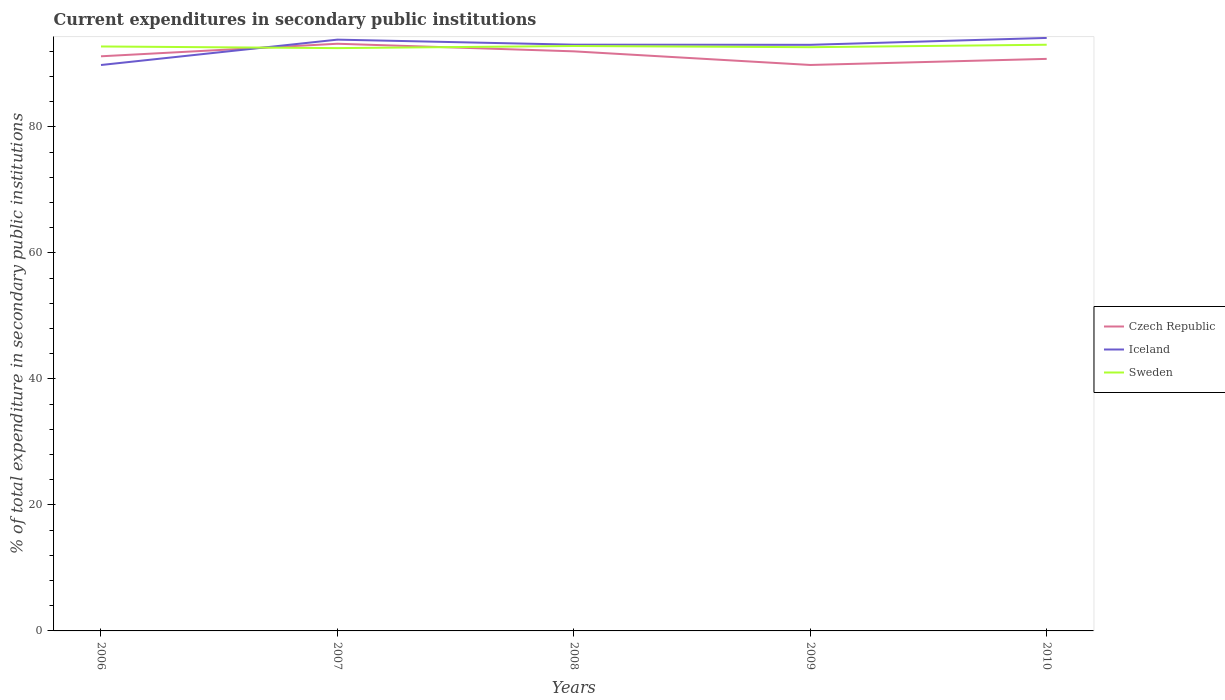How many different coloured lines are there?
Give a very brief answer. 3. Does the line corresponding to Czech Republic intersect with the line corresponding to Sweden?
Your answer should be compact. Yes. Across all years, what is the maximum current expenditures in secondary public institutions in Czech Republic?
Offer a terse response. 89.81. What is the total current expenditures in secondary public institutions in Sweden in the graph?
Your response must be concise. -0.28. What is the difference between the highest and the second highest current expenditures in secondary public institutions in Iceland?
Provide a succinct answer. 4.3. Is the current expenditures in secondary public institutions in Iceland strictly greater than the current expenditures in secondary public institutions in Czech Republic over the years?
Make the answer very short. No. How many lines are there?
Your answer should be very brief. 3. How many years are there in the graph?
Provide a succinct answer. 5. What is the difference between two consecutive major ticks on the Y-axis?
Your answer should be very brief. 20. Does the graph contain any zero values?
Give a very brief answer. No. Does the graph contain grids?
Offer a very short reply. No. How are the legend labels stacked?
Provide a short and direct response. Vertical. What is the title of the graph?
Provide a short and direct response. Current expenditures in secondary public institutions. Does "High income" appear as one of the legend labels in the graph?
Ensure brevity in your answer.  No. What is the label or title of the X-axis?
Make the answer very short. Years. What is the label or title of the Y-axis?
Provide a succinct answer. % of total expenditure in secondary public institutions. What is the % of total expenditure in secondary public institutions of Czech Republic in 2006?
Your response must be concise. 91.19. What is the % of total expenditure in secondary public institutions in Iceland in 2006?
Give a very brief answer. 89.81. What is the % of total expenditure in secondary public institutions of Sweden in 2006?
Keep it short and to the point. 92.75. What is the % of total expenditure in secondary public institutions of Czech Republic in 2007?
Your answer should be compact. 93.18. What is the % of total expenditure in secondary public institutions of Iceland in 2007?
Provide a succinct answer. 93.83. What is the % of total expenditure in secondary public institutions of Sweden in 2007?
Offer a terse response. 92.49. What is the % of total expenditure in secondary public institutions in Czech Republic in 2008?
Offer a terse response. 91.98. What is the % of total expenditure in secondary public institutions in Iceland in 2008?
Provide a short and direct response. 93.03. What is the % of total expenditure in secondary public institutions of Sweden in 2008?
Your response must be concise. 92.82. What is the % of total expenditure in secondary public institutions in Czech Republic in 2009?
Offer a terse response. 89.81. What is the % of total expenditure in secondary public institutions of Iceland in 2009?
Provide a succinct answer. 93.01. What is the % of total expenditure in secondary public institutions of Sweden in 2009?
Your answer should be very brief. 92.63. What is the % of total expenditure in secondary public institutions in Czech Republic in 2010?
Ensure brevity in your answer.  90.78. What is the % of total expenditure in secondary public institutions in Iceland in 2010?
Offer a very short reply. 94.1. What is the % of total expenditure in secondary public institutions of Sweden in 2010?
Ensure brevity in your answer.  93.02. Across all years, what is the maximum % of total expenditure in secondary public institutions of Czech Republic?
Offer a very short reply. 93.18. Across all years, what is the maximum % of total expenditure in secondary public institutions in Iceland?
Provide a succinct answer. 94.1. Across all years, what is the maximum % of total expenditure in secondary public institutions of Sweden?
Your answer should be compact. 93.02. Across all years, what is the minimum % of total expenditure in secondary public institutions of Czech Republic?
Make the answer very short. 89.81. Across all years, what is the minimum % of total expenditure in secondary public institutions in Iceland?
Give a very brief answer. 89.81. Across all years, what is the minimum % of total expenditure in secondary public institutions in Sweden?
Offer a terse response. 92.49. What is the total % of total expenditure in secondary public institutions in Czech Republic in the graph?
Make the answer very short. 456.94. What is the total % of total expenditure in secondary public institutions of Iceland in the graph?
Your answer should be compact. 463.79. What is the total % of total expenditure in secondary public institutions of Sweden in the graph?
Your answer should be very brief. 463.72. What is the difference between the % of total expenditure in secondary public institutions in Czech Republic in 2006 and that in 2007?
Ensure brevity in your answer.  -1.99. What is the difference between the % of total expenditure in secondary public institutions of Iceland in 2006 and that in 2007?
Your answer should be compact. -4.03. What is the difference between the % of total expenditure in secondary public institutions in Sweden in 2006 and that in 2007?
Your answer should be very brief. 0.26. What is the difference between the % of total expenditure in secondary public institutions of Czech Republic in 2006 and that in 2008?
Offer a very short reply. -0.79. What is the difference between the % of total expenditure in secondary public institutions in Iceland in 2006 and that in 2008?
Your response must be concise. -3.23. What is the difference between the % of total expenditure in secondary public institutions in Sweden in 2006 and that in 2008?
Provide a short and direct response. -0.07. What is the difference between the % of total expenditure in secondary public institutions of Czech Republic in 2006 and that in 2009?
Keep it short and to the point. 1.38. What is the difference between the % of total expenditure in secondary public institutions of Iceland in 2006 and that in 2009?
Keep it short and to the point. -3.2. What is the difference between the % of total expenditure in secondary public institutions in Sweden in 2006 and that in 2009?
Ensure brevity in your answer.  0.11. What is the difference between the % of total expenditure in secondary public institutions in Czech Republic in 2006 and that in 2010?
Provide a succinct answer. 0.41. What is the difference between the % of total expenditure in secondary public institutions of Iceland in 2006 and that in 2010?
Provide a succinct answer. -4.3. What is the difference between the % of total expenditure in secondary public institutions in Sweden in 2006 and that in 2010?
Keep it short and to the point. -0.28. What is the difference between the % of total expenditure in secondary public institutions of Czech Republic in 2007 and that in 2008?
Give a very brief answer. 1.2. What is the difference between the % of total expenditure in secondary public institutions in Iceland in 2007 and that in 2008?
Give a very brief answer. 0.8. What is the difference between the % of total expenditure in secondary public institutions of Sweden in 2007 and that in 2008?
Offer a very short reply. -0.33. What is the difference between the % of total expenditure in secondary public institutions of Czech Republic in 2007 and that in 2009?
Your response must be concise. 3.37. What is the difference between the % of total expenditure in secondary public institutions in Iceland in 2007 and that in 2009?
Ensure brevity in your answer.  0.82. What is the difference between the % of total expenditure in secondary public institutions of Sweden in 2007 and that in 2009?
Offer a terse response. -0.15. What is the difference between the % of total expenditure in secondary public institutions in Czech Republic in 2007 and that in 2010?
Provide a succinct answer. 2.4. What is the difference between the % of total expenditure in secondary public institutions in Iceland in 2007 and that in 2010?
Your answer should be compact. -0.27. What is the difference between the % of total expenditure in secondary public institutions in Sweden in 2007 and that in 2010?
Provide a succinct answer. -0.54. What is the difference between the % of total expenditure in secondary public institutions of Czech Republic in 2008 and that in 2009?
Ensure brevity in your answer.  2.16. What is the difference between the % of total expenditure in secondary public institutions in Iceland in 2008 and that in 2009?
Give a very brief answer. 0.02. What is the difference between the % of total expenditure in secondary public institutions in Sweden in 2008 and that in 2009?
Your response must be concise. 0.19. What is the difference between the % of total expenditure in secondary public institutions in Czech Republic in 2008 and that in 2010?
Provide a short and direct response. 1.2. What is the difference between the % of total expenditure in secondary public institutions of Iceland in 2008 and that in 2010?
Make the answer very short. -1.07. What is the difference between the % of total expenditure in secondary public institutions in Sweden in 2008 and that in 2010?
Ensure brevity in your answer.  -0.2. What is the difference between the % of total expenditure in secondary public institutions of Czech Republic in 2009 and that in 2010?
Keep it short and to the point. -0.97. What is the difference between the % of total expenditure in secondary public institutions in Iceland in 2009 and that in 2010?
Provide a succinct answer. -1.09. What is the difference between the % of total expenditure in secondary public institutions of Sweden in 2009 and that in 2010?
Make the answer very short. -0.39. What is the difference between the % of total expenditure in secondary public institutions in Czech Republic in 2006 and the % of total expenditure in secondary public institutions in Iceland in 2007?
Offer a very short reply. -2.64. What is the difference between the % of total expenditure in secondary public institutions of Czech Republic in 2006 and the % of total expenditure in secondary public institutions of Sweden in 2007?
Provide a short and direct response. -1.3. What is the difference between the % of total expenditure in secondary public institutions of Iceland in 2006 and the % of total expenditure in secondary public institutions of Sweden in 2007?
Make the answer very short. -2.68. What is the difference between the % of total expenditure in secondary public institutions in Czech Republic in 2006 and the % of total expenditure in secondary public institutions in Iceland in 2008?
Provide a succinct answer. -1.84. What is the difference between the % of total expenditure in secondary public institutions in Czech Republic in 2006 and the % of total expenditure in secondary public institutions in Sweden in 2008?
Your response must be concise. -1.63. What is the difference between the % of total expenditure in secondary public institutions of Iceland in 2006 and the % of total expenditure in secondary public institutions of Sweden in 2008?
Offer a very short reply. -3.01. What is the difference between the % of total expenditure in secondary public institutions in Czech Republic in 2006 and the % of total expenditure in secondary public institutions in Iceland in 2009?
Your answer should be compact. -1.82. What is the difference between the % of total expenditure in secondary public institutions in Czech Republic in 2006 and the % of total expenditure in secondary public institutions in Sweden in 2009?
Make the answer very short. -1.44. What is the difference between the % of total expenditure in secondary public institutions in Iceland in 2006 and the % of total expenditure in secondary public institutions in Sweden in 2009?
Keep it short and to the point. -2.83. What is the difference between the % of total expenditure in secondary public institutions in Czech Republic in 2006 and the % of total expenditure in secondary public institutions in Iceland in 2010?
Keep it short and to the point. -2.91. What is the difference between the % of total expenditure in secondary public institutions of Czech Republic in 2006 and the % of total expenditure in secondary public institutions of Sweden in 2010?
Keep it short and to the point. -1.83. What is the difference between the % of total expenditure in secondary public institutions in Iceland in 2006 and the % of total expenditure in secondary public institutions in Sweden in 2010?
Your response must be concise. -3.22. What is the difference between the % of total expenditure in secondary public institutions in Czech Republic in 2007 and the % of total expenditure in secondary public institutions in Iceland in 2008?
Make the answer very short. 0.15. What is the difference between the % of total expenditure in secondary public institutions in Czech Republic in 2007 and the % of total expenditure in secondary public institutions in Sweden in 2008?
Offer a very short reply. 0.36. What is the difference between the % of total expenditure in secondary public institutions in Iceland in 2007 and the % of total expenditure in secondary public institutions in Sweden in 2008?
Your answer should be very brief. 1.01. What is the difference between the % of total expenditure in secondary public institutions of Czech Republic in 2007 and the % of total expenditure in secondary public institutions of Iceland in 2009?
Provide a succinct answer. 0.17. What is the difference between the % of total expenditure in secondary public institutions in Czech Republic in 2007 and the % of total expenditure in secondary public institutions in Sweden in 2009?
Give a very brief answer. 0.55. What is the difference between the % of total expenditure in secondary public institutions of Iceland in 2007 and the % of total expenditure in secondary public institutions of Sweden in 2009?
Offer a very short reply. 1.2. What is the difference between the % of total expenditure in secondary public institutions in Czech Republic in 2007 and the % of total expenditure in secondary public institutions in Iceland in 2010?
Provide a short and direct response. -0.92. What is the difference between the % of total expenditure in secondary public institutions of Czech Republic in 2007 and the % of total expenditure in secondary public institutions of Sweden in 2010?
Provide a succinct answer. 0.16. What is the difference between the % of total expenditure in secondary public institutions of Iceland in 2007 and the % of total expenditure in secondary public institutions of Sweden in 2010?
Ensure brevity in your answer.  0.81. What is the difference between the % of total expenditure in secondary public institutions in Czech Republic in 2008 and the % of total expenditure in secondary public institutions in Iceland in 2009?
Keep it short and to the point. -1.04. What is the difference between the % of total expenditure in secondary public institutions of Czech Republic in 2008 and the % of total expenditure in secondary public institutions of Sweden in 2009?
Keep it short and to the point. -0.66. What is the difference between the % of total expenditure in secondary public institutions in Iceland in 2008 and the % of total expenditure in secondary public institutions in Sweden in 2009?
Provide a succinct answer. 0.4. What is the difference between the % of total expenditure in secondary public institutions in Czech Republic in 2008 and the % of total expenditure in secondary public institutions in Iceland in 2010?
Give a very brief answer. -2.13. What is the difference between the % of total expenditure in secondary public institutions of Czech Republic in 2008 and the % of total expenditure in secondary public institutions of Sweden in 2010?
Your response must be concise. -1.05. What is the difference between the % of total expenditure in secondary public institutions in Iceland in 2008 and the % of total expenditure in secondary public institutions in Sweden in 2010?
Offer a very short reply. 0.01. What is the difference between the % of total expenditure in secondary public institutions in Czech Republic in 2009 and the % of total expenditure in secondary public institutions in Iceland in 2010?
Make the answer very short. -4.29. What is the difference between the % of total expenditure in secondary public institutions of Czech Republic in 2009 and the % of total expenditure in secondary public institutions of Sweden in 2010?
Provide a succinct answer. -3.21. What is the difference between the % of total expenditure in secondary public institutions of Iceland in 2009 and the % of total expenditure in secondary public institutions of Sweden in 2010?
Keep it short and to the point. -0.01. What is the average % of total expenditure in secondary public institutions in Czech Republic per year?
Provide a short and direct response. 91.39. What is the average % of total expenditure in secondary public institutions in Iceland per year?
Your answer should be compact. 92.76. What is the average % of total expenditure in secondary public institutions in Sweden per year?
Offer a very short reply. 92.74. In the year 2006, what is the difference between the % of total expenditure in secondary public institutions of Czech Republic and % of total expenditure in secondary public institutions of Iceland?
Your answer should be very brief. 1.38. In the year 2006, what is the difference between the % of total expenditure in secondary public institutions of Czech Republic and % of total expenditure in secondary public institutions of Sweden?
Offer a very short reply. -1.56. In the year 2006, what is the difference between the % of total expenditure in secondary public institutions of Iceland and % of total expenditure in secondary public institutions of Sweden?
Provide a succinct answer. -2.94. In the year 2007, what is the difference between the % of total expenditure in secondary public institutions of Czech Republic and % of total expenditure in secondary public institutions of Iceland?
Provide a succinct answer. -0.65. In the year 2007, what is the difference between the % of total expenditure in secondary public institutions of Czech Republic and % of total expenditure in secondary public institutions of Sweden?
Your response must be concise. 0.69. In the year 2007, what is the difference between the % of total expenditure in secondary public institutions of Iceland and % of total expenditure in secondary public institutions of Sweden?
Your answer should be very brief. 1.34. In the year 2008, what is the difference between the % of total expenditure in secondary public institutions of Czech Republic and % of total expenditure in secondary public institutions of Iceland?
Offer a very short reply. -1.06. In the year 2008, what is the difference between the % of total expenditure in secondary public institutions of Czech Republic and % of total expenditure in secondary public institutions of Sweden?
Your answer should be compact. -0.84. In the year 2008, what is the difference between the % of total expenditure in secondary public institutions of Iceland and % of total expenditure in secondary public institutions of Sweden?
Your response must be concise. 0.21. In the year 2009, what is the difference between the % of total expenditure in secondary public institutions in Czech Republic and % of total expenditure in secondary public institutions in Iceland?
Give a very brief answer. -3.2. In the year 2009, what is the difference between the % of total expenditure in secondary public institutions in Czech Republic and % of total expenditure in secondary public institutions in Sweden?
Your answer should be very brief. -2.82. In the year 2009, what is the difference between the % of total expenditure in secondary public institutions in Iceland and % of total expenditure in secondary public institutions in Sweden?
Provide a succinct answer. 0.38. In the year 2010, what is the difference between the % of total expenditure in secondary public institutions of Czech Republic and % of total expenditure in secondary public institutions of Iceland?
Offer a terse response. -3.32. In the year 2010, what is the difference between the % of total expenditure in secondary public institutions in Czech Republic and % of total expenditure in secondary public institutions in Sweden?
Your answer should be compact. -2.24. In the year 2010, what is the difference between the % of total expenditure in secondary public institutions in Iceland and % of total expenditure in secondary public institutions in Sweden?
Make the answer very short. 1.08. What is the ratio of the % of total expenditure in secondary public institutions in Czech Republic in 2006 to that in 2007?
Offer a terse response. 0.98. What is the ratio of the % of total expenditure in secondary public institutions of Iceland in 2006 to that in 2007?
Your response must be concise. 0.96. What is the ratio of the % of total expenditure in secondary public institutions of Czech Republic in 2006 to that in 2008?
Offer a very short reply. 0.99. What is the ratio of the % of total expenditure in secondary public institutions in Iceland in 2006 to that in 2008?
Your answer should be very brief. 0.97. What is the ratio of the % of total expenditure in secondary public institutions in Czech Republic in 2006 to that in 2009?
Keep it short and to the point. 1.02. What is the ratio of the % of total expenditure in secondary public institutions of Iceland in 2006 to that in 2009?
Provide a short and direct response. 0.97. What is the ratio of the % of total expenditure in secondary public institutions of Sweden in 2006 to that in 2009?
Provide a succinct answer. 1. What is the ratio of the % of total expenditure in secondary public institutions of Iceland in 2006 to that in 2010?
Provide a short and direct response. 0.95. What is the ratio of the % of total expenditure in secondary public institutions in Czech Republic in 2007 to that in 2008?
Provide a short and direct response. 1.01. What is the ratio of the % of total expenditure in secondary public institutions in Iceland in 2007 to that in 2008?
Ensure brevity in your answer.  1.01. What is the ratio of the % of total expenditure in secondary public institutions of Czech Republic in 2007 to that in 2009?
Provide a succinct answer. 1.04. What is the ratio of the % of total expenditure in secondary public institutions of Iceland in 2007 to that in 2009?
Your answer should be compact. 1.01. What is the ratio of the % of total expenditure in secondary public institutions of Sweden in 2007 to that in 2009?
Your response must be concise. 1. What is the ratio of the % of total expenditure in secondary public institutions of Czech Republic in 2007 to that in 2010?
Offer a very short reply. 1.03. What is the ratio of the % of total expenditure in secondary public institutions in Czech Republic in 2008 to that in 2009?
Give a very brief answer. 1.02. What is the ratio of the % of total expenditure in secondary public institutions of Iceland in 2008 to that in 2009?
Your answer should be very brief. 1. What is the ratio of the % of total expenditure in secondary public institutions in Czech Republic in 2008 to that in 2010?
Provide a short and direct response. 1.01. What is the ratio of the % of total expenditure in secondary public institutions of Sweden in 2008 to that in 2010?
Your answer should be compact. 1. What is the ratio of the % of total expenditure in secondary public institutions of Czech Republic in 2009 to that in 2010?
Provide a succinct answer. 0.99. What is the ratio of the % of total expenditure in secondary public institutions in Iceland in 2009 to that in 2010?
Make the answer very short. 0.99. What is the difference between the highest and the second highest % of total expenditure in secondary public institutions in Czech Republic?
Your answer should be very brief. 1.2. What is the difference between the highest and the second highest % of total expenditure in secondary public institutions in Iceland?
Provide a succinct answer. 0.27. What is the difference between the highest and the second highest % of total expenditure in secondary public institutions in Sweden?
Your response must be concise. 0.2. What is the difference between the highest and the lowest % of total expenditure in secondary public institutions of Czech Republic?
Keep it short and to the point. 3.37. What is the difference between the highest and the lowest % of total expenditure in secondary public institutions in Iceland?
Your answer should be compact. 4.3. What is the difference between the highest and the lowest % of total expenditure in secondary public institutions in Sweden?
Keep it short and to the point. 0.54. 